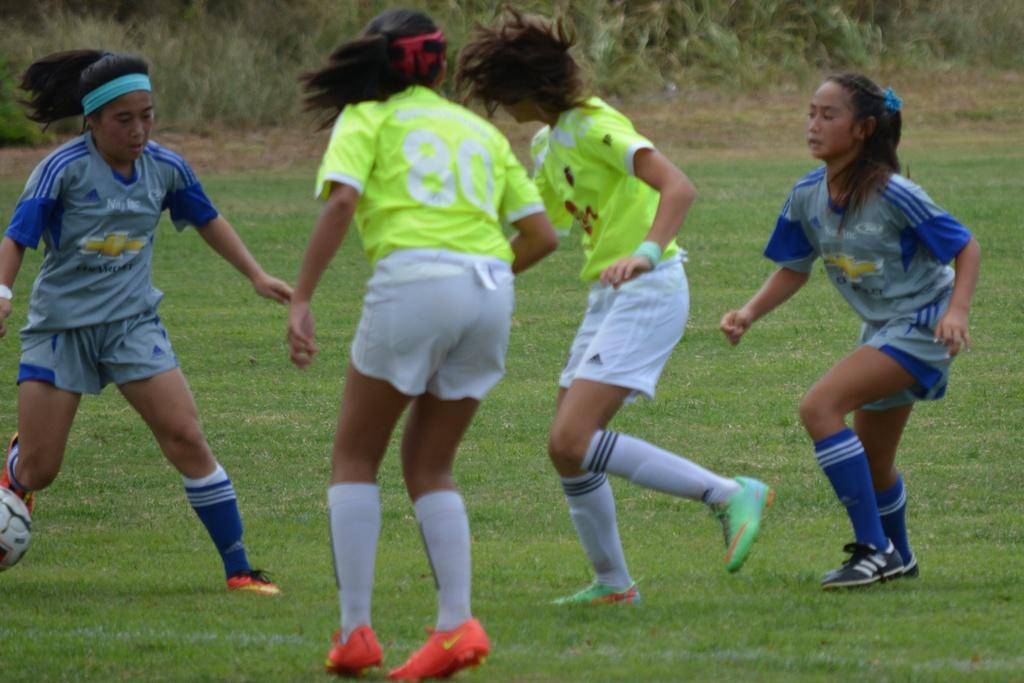Please provide a concise description of this image. In this image I can see four people are on the ground. These people are wearing the different color jerseys and to the left there is a ball. In the background I can see many trees. 